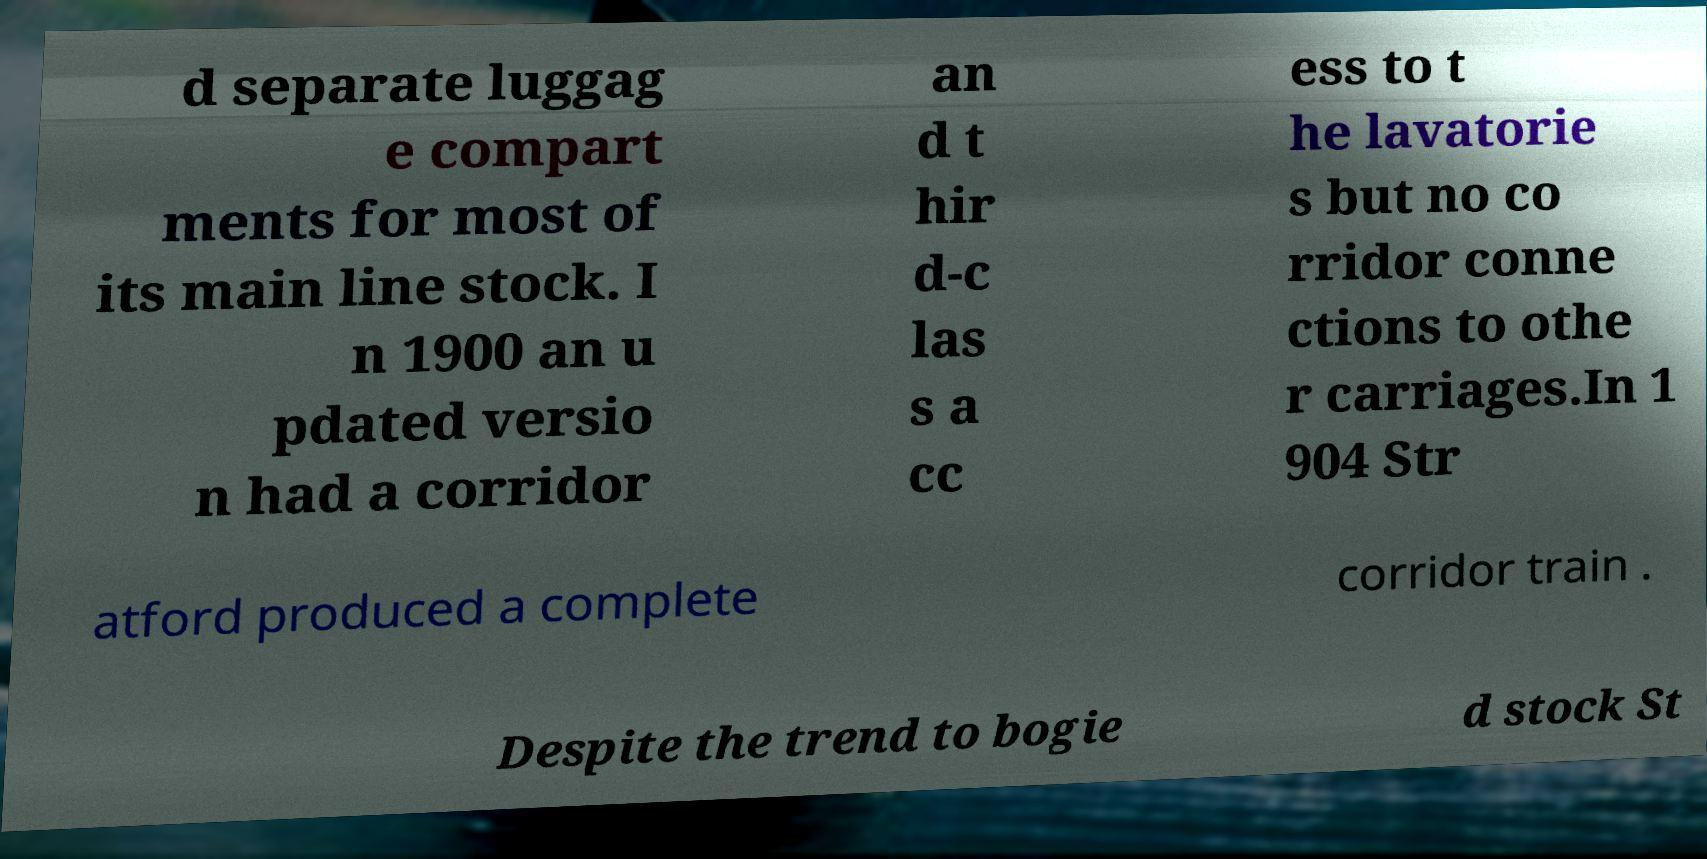For documentation purposes, I need the text within this image transcribed. Could you provide that? d separate luggag e compart ments for most of its main line stock. I n 1900 an u pdated versio n had a corridor an d t hir d-c las s a cc ess to t he lavatorie s but no co rridor conne ctions to othe r carriages.In 1 904 Str atford produced a complete corridor train . Despite the trend to bogie d stock St 